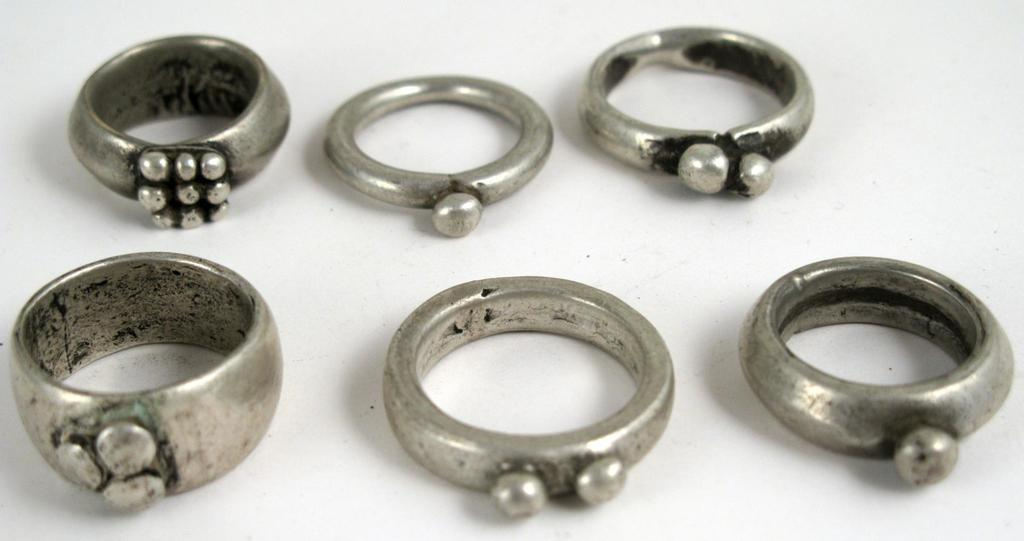What type of jewelry is present in the image? There are silver rings in the image. What color is the background of the image? The background of the image is white. What type of force is being applied to the rings in the image? There is no indication of any force being applied to the rings in the image. What is the monetary value of the rings in the image? The image does not provide any information about the value of the rings. 